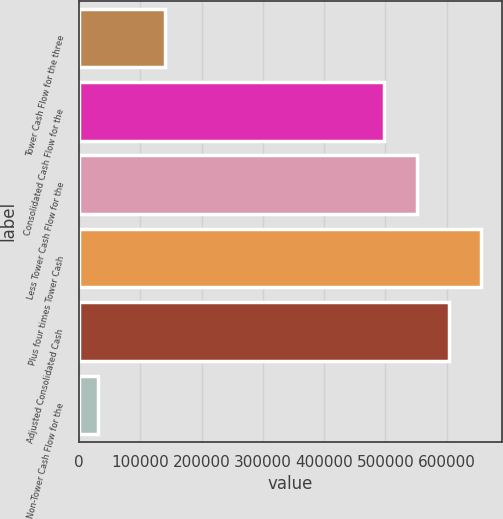Convert chart. <chart><loc_0><loc_0><loc_500><loc_500><bar_chart><fcel>Tower Cash Flow for the three<fcel>Consolidated Cash Flow for the<fcel>Less Tower Cash Flow for the<fcel>Plus four times Tower Cash<fcel>Adjusted Consolidated Cash<fcel>Non-Tower Cash Flow for the<nl><fcel>139590<fcel>498266<fcel>551044<fcel>656599<fcel>603821<fcel>30584<nl></chart> 